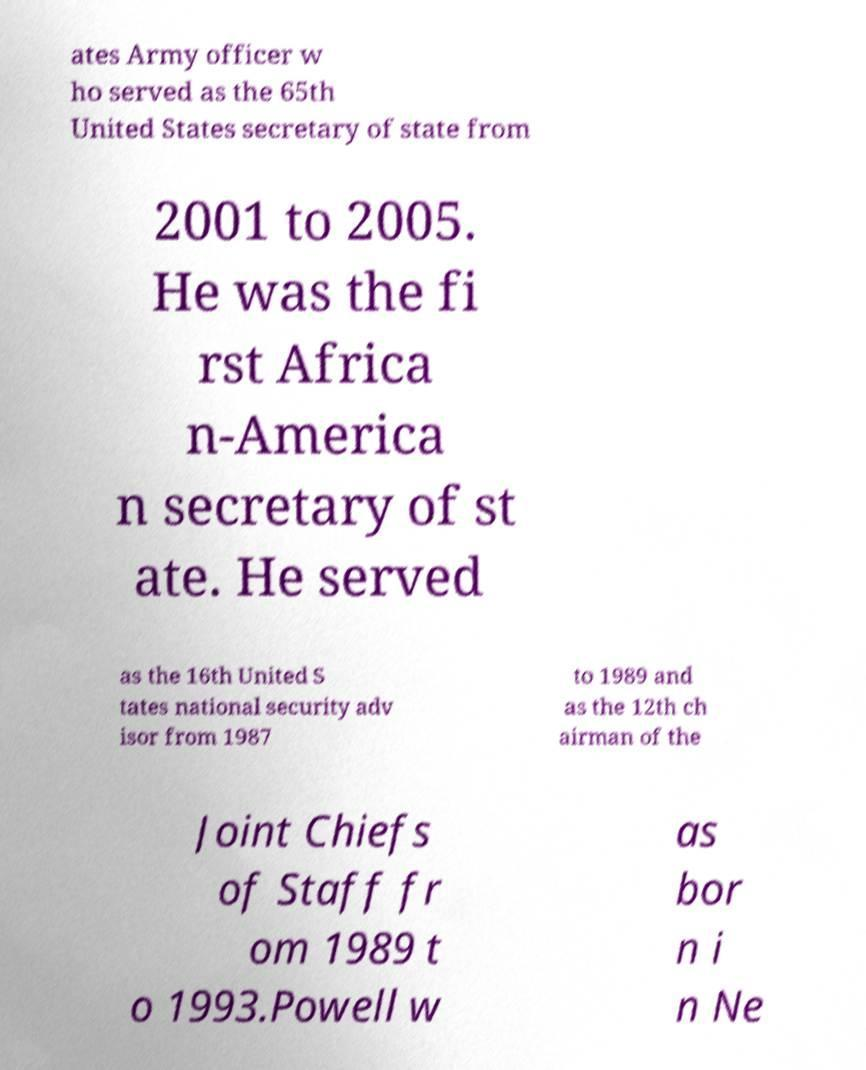I need the written content from this picture converted into text. Can you do that? ates Army officer w ho served as the 65th United States secretary of state from 2001 to 2005. He was the fi rst Africa n-America n secretary of st ate. He served as the 16th United S tates national security adv isor from 1987 to 1989 and as the 12th ch airman of the Joint Chiefs of Staff fr om 1989 t o 1993.Powell w as bor n i n Ne 